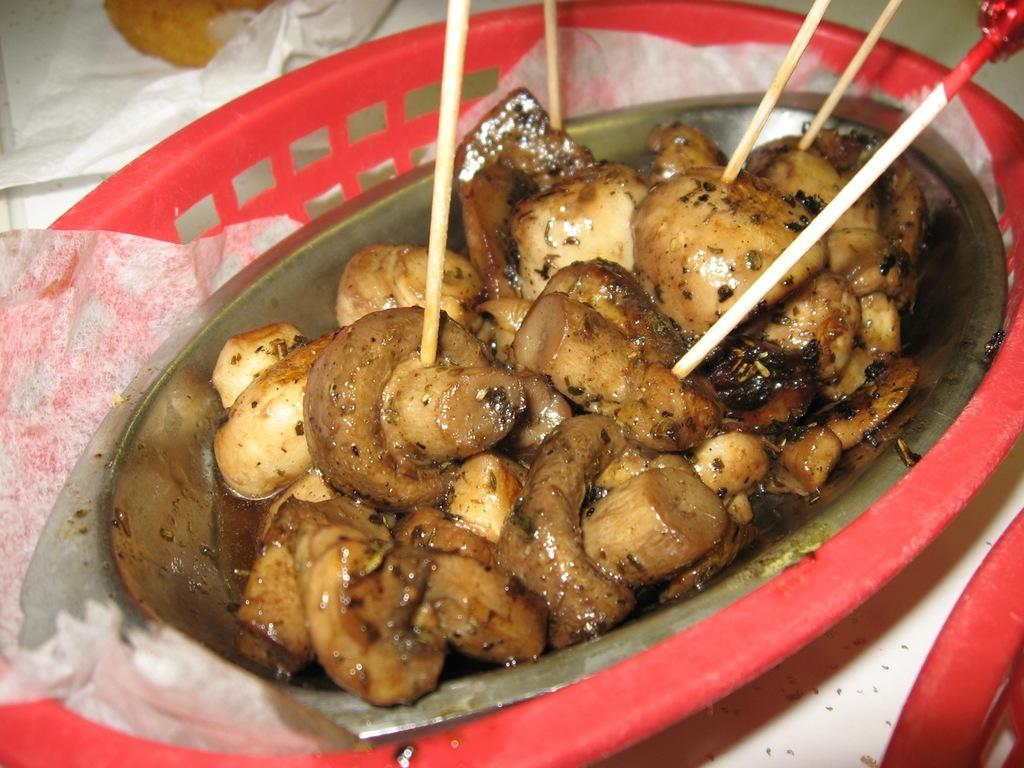What is the main structure in the center of the image? There is a platform in the center of the image. What is placed on top of the platform? There is a basket on the platform. What else can be found on the platform besides the basket? Tissue papers, food items, and other objects are present on the platform. How many icicles are hanging from the platform in the image? There are no icicles present in the image. What type of territory is depicted in the image? The image does not show any territory; it features a platform with various items on it. 